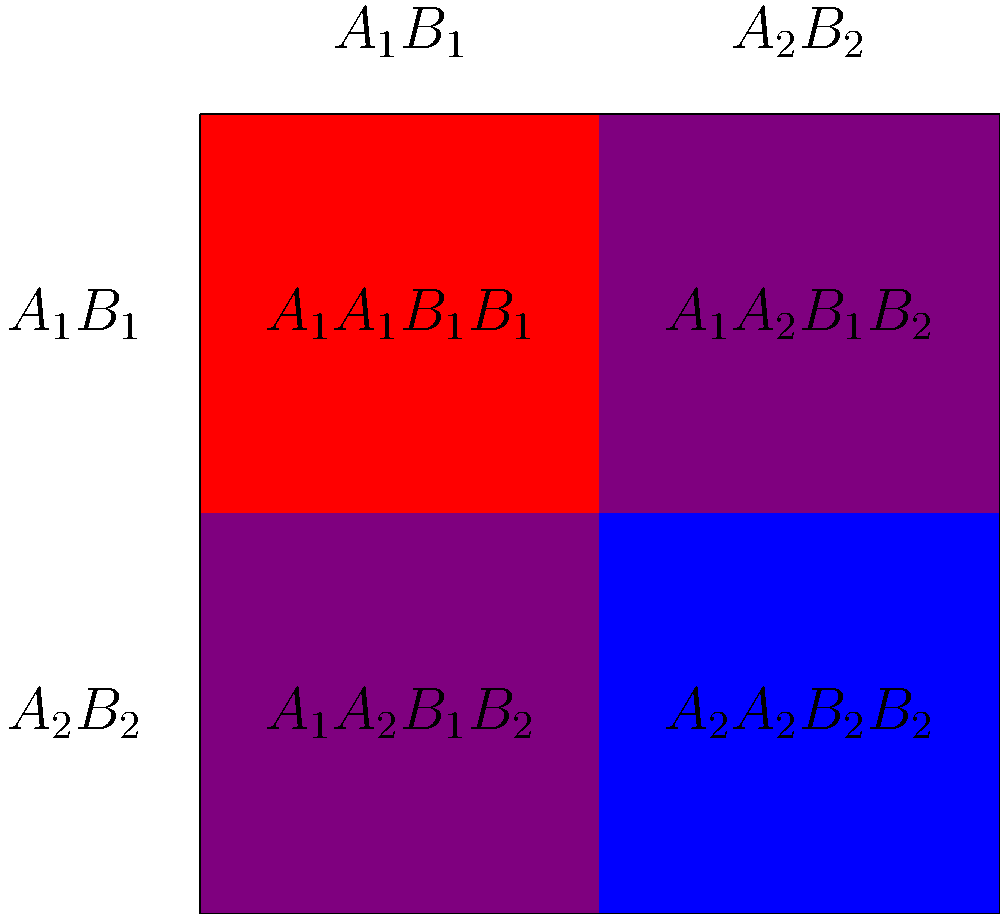In a complex trait inheritance study, you're examining the coat color in a novel dog breed. The trait is influenced by two genes, A and B, each with two alleles. $A_1$ and $B_1$ are dominant, while $A_2$ and $B_2$ are recessive. The presence of both dominant alleles ($A_1$ and $B_1$) results in a red coat, both recessive alleles ($A_2$ and $B_2$) produce a blue coat, and any other combination leads to a purple coat. Given the Punnett square above representing a cross between two heterozygous parents ($A_1A_2B_1B_2$), what is the probability of producing offspring with a purple coat? To solve this problem, we need to follow these steps:

1. Understand the genotype-phenotype relationship:
   - Red coat: $A_1\_B_1\_$ (at least one dominant allele of each gene)
   - Blue coat: $A_2A_2B_2B_2$ (both recessive alleles for both genes)
   - Purple coat: Any other combination

2. Analyze the Punnett square:
   - The square shows the possible genotype combinations from two heterozygous parents ($A_1A_2B_1B_2$).

3. Identify the genotypes that result in a purple coat:
   - $A_1A_2B_1B_2$
   - $A_1A_2B_1B_2$

4. Count the number of purple coat outcomes:
   - There are 2 purple coat outcomes out of 4 total possibilities.

5. Calculate the probability:
   - Probability = Number of favorable outcomes / Total number of possible outcomes
   - Probability of purple coat = 2 / 4 = 1 / 2 = 0.5 or 50%

Therefore, the probability of producing offspring with a purple coat from this cross is 1/2 or 50%.
Answer: 1/2 or 50% 